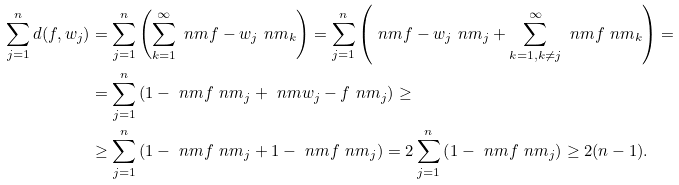Convert formula to latex. <formula><loc_0><loc_0><loc_500><loc_500>\sum _ { j = 1 } ^ { n } d ( f , w _ { j } ) & = \sum _ { j = 1 } ^ { n } \left ( \sum _ { k = 1 } ^ { \infty } \ n m f - w _ { j } \ n m _ { k } \right ) = \sum _ { j = 1 } ^ { n } \left ( \ n m f - w _ { j } \ n m _ { j } + \sum _ { k = 1 , k \ne j } ^ { \infty } \ n m f \ n m _ { k } \right ) = \\ & = \sum _ { j = 1 } ^ { n } \left ( 1 - \ n m f \ n m _ { j } + \ n m w _ { j } - f \ n m _ { j } \right ) \geq \\ & \geq \sum _ { j = 1 } ^ { n } \left ( 1 - \ n m f \ n m _ { j } + 1 - \ n m f \ n m _ { j } \right ) = 2 \sum _ { j = 1 } ^ { n } \left ( 1 - \ n m f \ n m _ { j } \right ) \geq 2 ( n - 1 ) .</formula> 